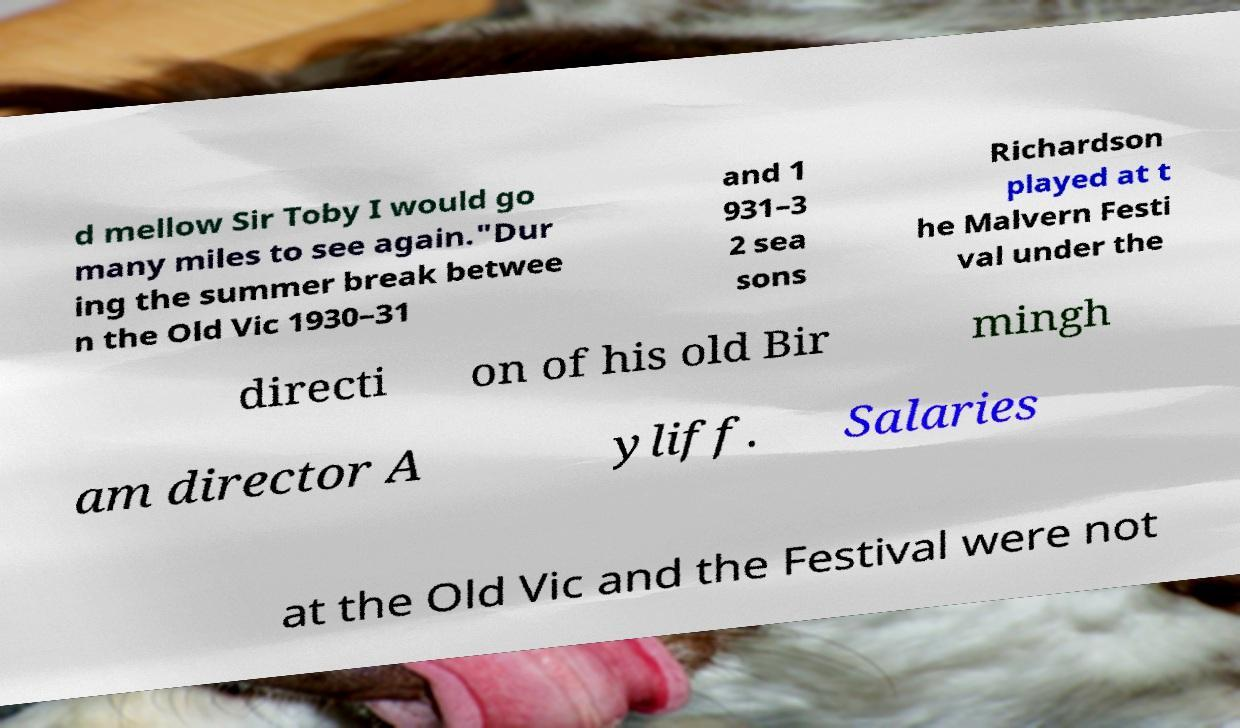Can you read and provide the text displayed in the image?This photo seems to have some interesting text. Can you extract and type it out for me? d mellow Sir Toby I would go many miles to see again."Dur ing the summer break betwee n the Old Vic 1930–31 and 1 931–3 2 sea sons Richardson played at t he Malvern Festi val under the directi on of his old Bir mingh am director A yliff. Salaries at the Old Vic and the Festival were not 